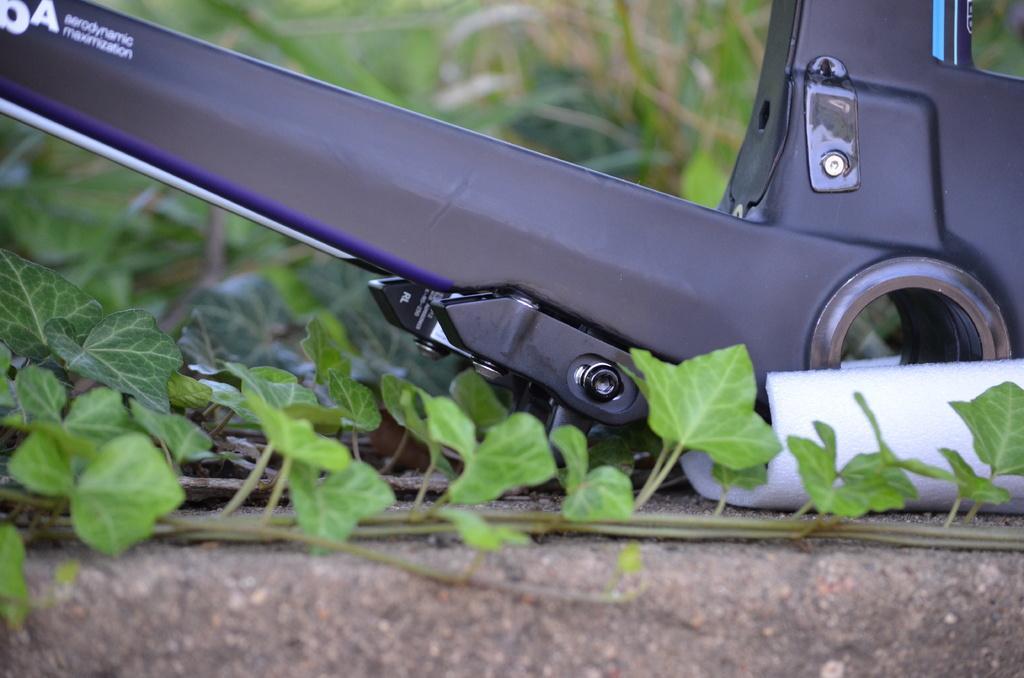How would you summarize this image in a sentence or two? In this picture we can see one object is placed on the land, side we can see few plants. 